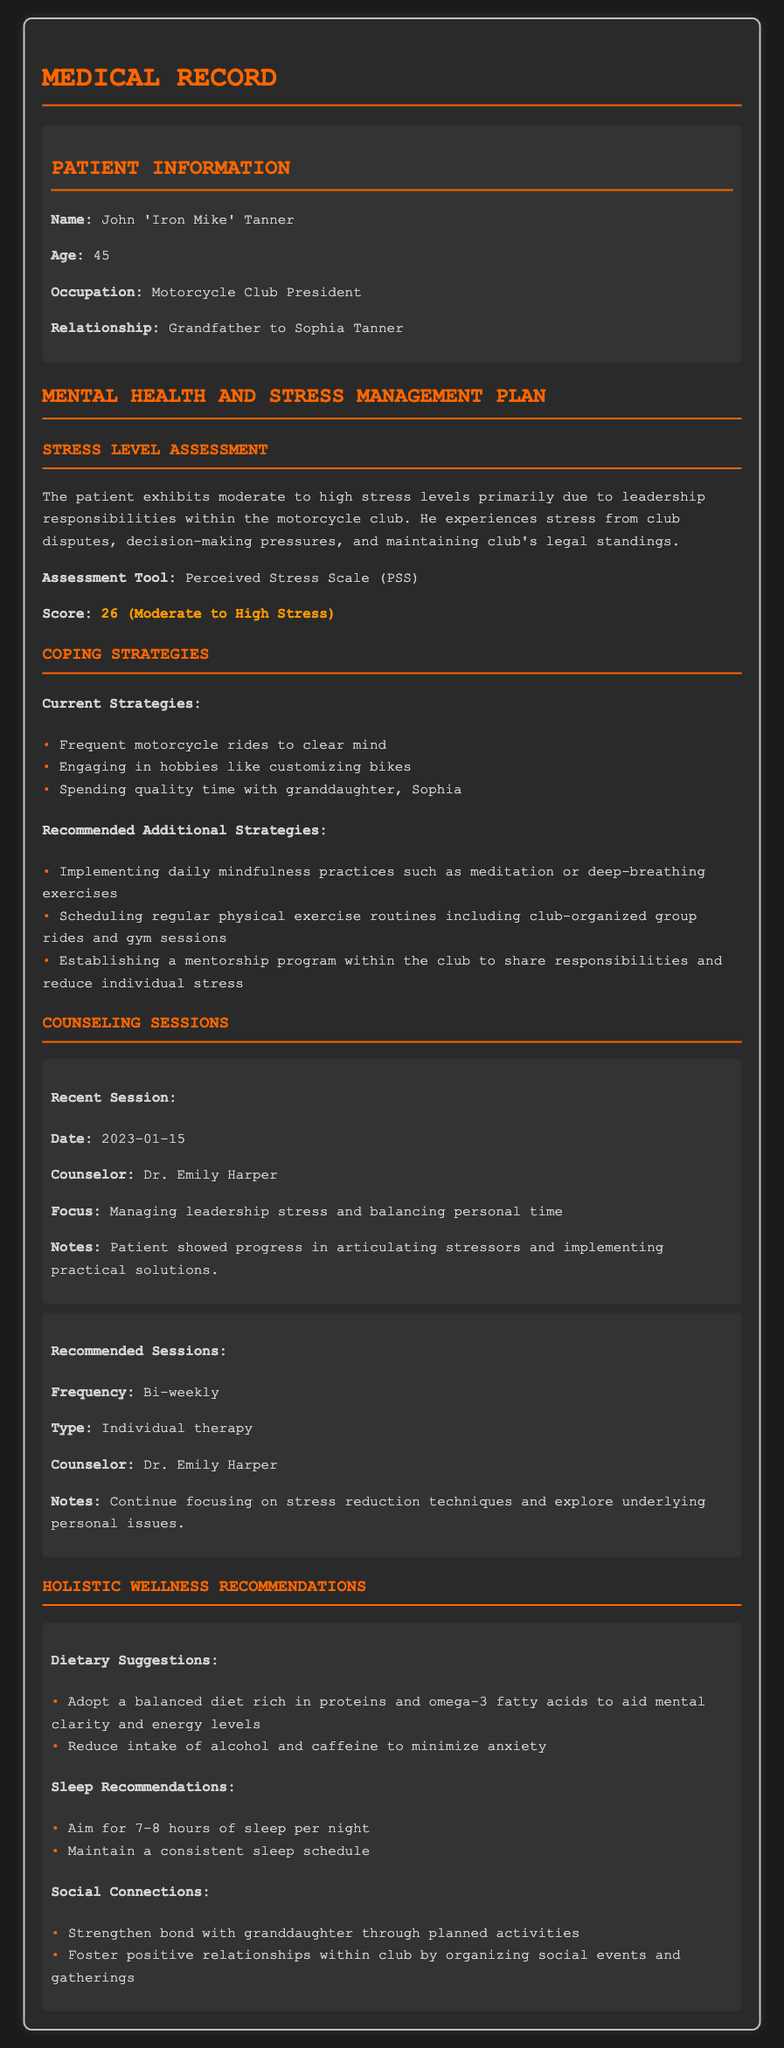What is the patient's name? The patient's name is listed in the patient information section of the document.
Answer: John 'Iron Mike' Tanner What is the patient's age? The patient's age is explicitly mentioned in the patient information section.
Answer: 45 What is the stress level score? The stress level score is provided in the stress level assessment section of the document.
Answer: 26 (Moderate to High Stress) Who is the counselor for the recommended sessions? The name of the counselor is stated in the counseling sessions section.
Answer: Dr. Emily Harper What coping strategy involves spending time with family? The coping strategy involves spending quality time with his granddaughter mentioned in the coping strategies section.
Answer: Spending quality time with granddaughter, Sophia What type of therapy is recommended for the patient? The recommended type of therapy is specified in the counseling sessions section.
Answer: Individual therapy What dietary suggestion is made regarding alcohol? The suggestion is found in the dietary recommendations listed under holistic wellness recommendations.
Answer: Reduce intake of alcohol How often are the recommended counseling sessions? The frequency of the recommended sessions is detailed in the counseling sessions section.
Answer: Bi-weekly What is one of the sleep recommendations? The sleep recommendations are outlined in the holistic wellness recommendations section.
Answer: Aim for 7-8 hours of sleep per night 